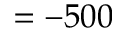Convert formula to latex. <formula><loc_0><loc_0><loc_500><loc_500>= - 5 0 0</formula> 